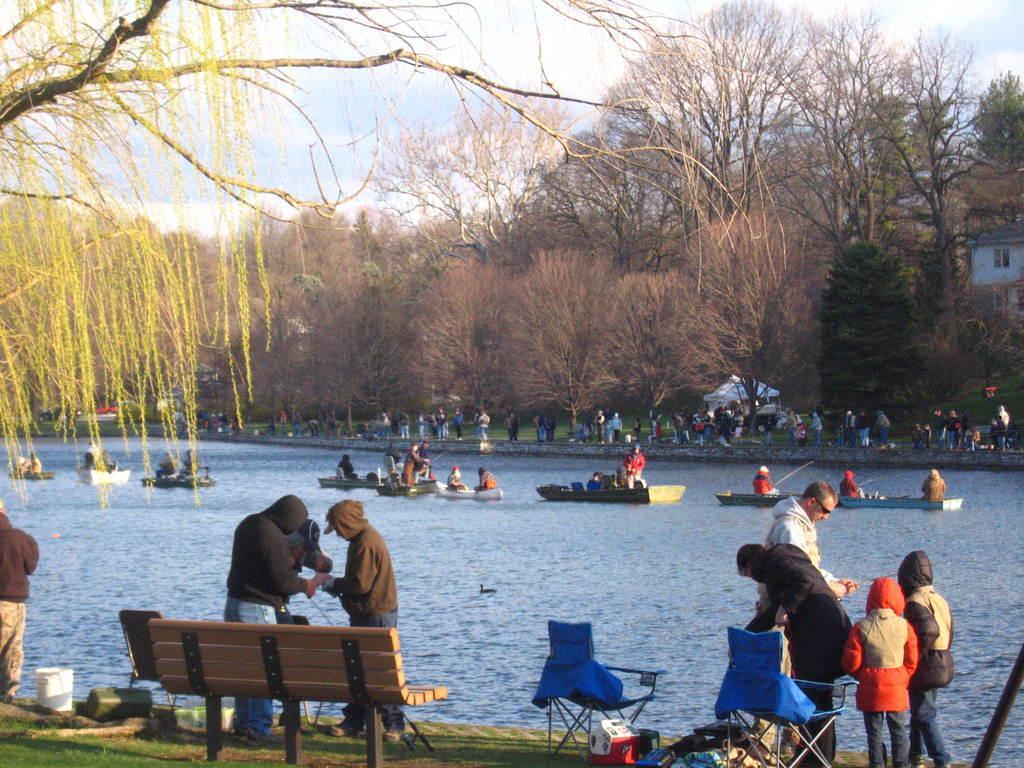Could you give a brief overview of what you see in this image? In this image I can see few people sitting in the boats and the boats are on the water and I can see few people standing, few chairs and the bench. In the background I can see few trees, buildings and the sky is in white and blue color. 